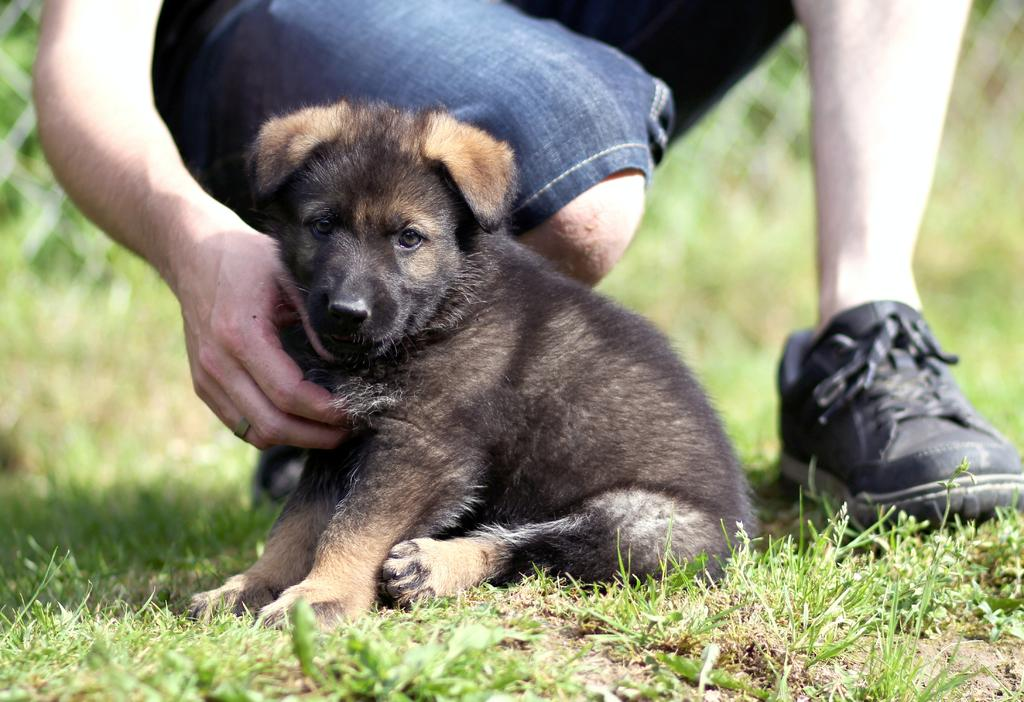What animal is present in the image? There is a puppy in the image. Where is the puppy located? The puppy is sitting on a grass path. What is the person in the image doing? The person is in a squat position. Can you describe the background of the image? The background of the image is blurred. What type of chalk is the puppy using to draw on the grass path? There is no chalk present in the image, and the puppy is not drawing on the grass path. 